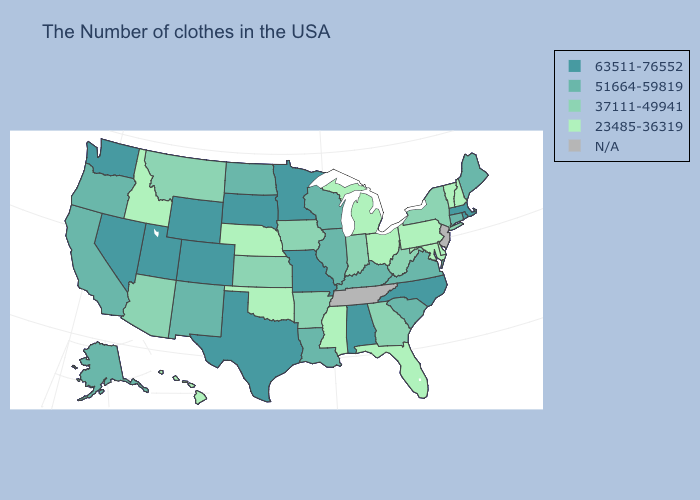Among the states that border Montana , does Idaho have the lowest value?
Be succinct. Yes. What is the highest value in the USA?
Give a very brief answer. 63511-76552. Which states have the lowest value in the USA?
Quick response, please. New Hampshire, Vermont, Delaware, Maryland, Pennsylvania, Ohio, Florida, Michigan, Mississippi, Nebraska, Oklahoma, Idaho, Hawaii. What is the highest value in states that border Alabama?
Answer briefly. 37111-49941. What is the highest value in the MidWest ?
Answer briefly. 63511-76552. What is the highest value in states that border Arkansas?
Concise answer only. 63511-76552. Name the states that have a value in the range 63511-76552?
Short answer required. Massachusetts, Rhode Island, North Carolina, Alabama, Missouri, Minnesota, Texas, South Dakota, Wyoming, Colorado, Utah, Nevada, Washington. Does the map have missing data?
Write a very short answer. Yes. Name the states that have a value in the range 23485-36319?
Quick response, please. New Hampshire, Vermont, Delaware, Maryland, Pennsylvania, Ohio, Florida, Michigan, Mississippi, Nebraska, Oklahoma, Idaho, Hawaii. Does New Hampshire have the lowest value in the USA?
Give a very brief answer. Yes. Name the states that have a value in the range 51664-59819?
Concise answer only. Maine, Connecticut, Virginia, South Carolina, Kentucky, Wisconsin, Illinois, Louisiana, North Dakota, New Mexico, California, Oregon, Alaska. How many symbols are there in the legend?
Be succinct. 5. Name the states that have a value in the range 51664-59819?
Keep it brief. Maine, Connecticut, Virginia, South Carolina, Kentucky, Wisconsin, Illinois, Louisiana, North Dakota, New Mexico, California, Oregon, Alaska. Name the states that have a value in the range 51664-59819?
Write a very short answer. Maine, Connecticut, Virginia, South Carolina, Kentucky, Wisconsin, Illinois, Louisiana, North Dakota, New Mexico, California, Oregon, Alaska. 